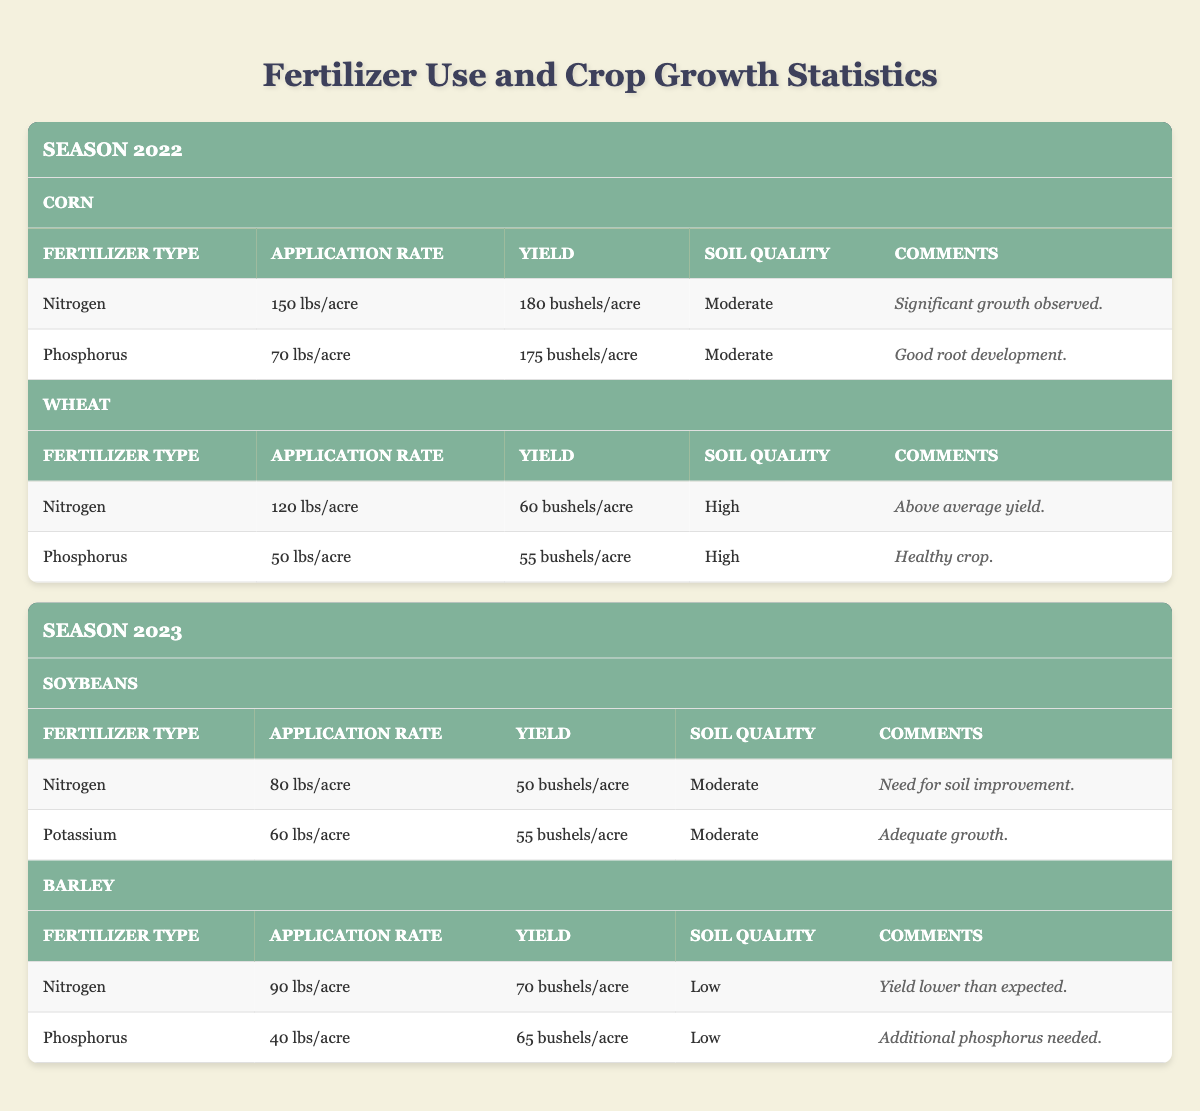What is the yield of corn for the 2022 season? The yield for corn in the 2022 season is listed under the respective row for corn in that season. Looking closely, it indicates a yield of 180 bushels/acre.
Answer: 180 bushels/acre What type of fertilizer was used for wheat in the 2022 season? The table has a specific row for wheat in the 2022 season that lists the fertilizers used. The types listed are nitrogen and phosphorus.
Answer: Nitrogen and phosphorus Which crop had a higher yield in 2022, corn or wheat? By comparing the yields listed in the table, corn has a yield of 180 bushels/acre, while wheat has a yield of 60 bushels/acre. Clearly, corn has a higher yield than wheat.
Answer: Corn What was the total application rate of nitrogen used for corn in the 2022 season? The application rate for nitrogen for corn is given directly in the table as 150 lbs/acre. This is the single fertilizer application rate for corn in that season.
Answer: 150 lbs/acre Does the 2023 season show an increase in yield for soybeans compared to the yield of wheat in the 2022 season? The yield for soybeans in 2023 is 50 bushels/acre, while the yield for wheat in 2022 is 60 bushels/acre. Therefore, the yield for soybeans did not increase compared to wheat; it decreased.
Answer: No What is the average yield of barley in the 2023 season? Both nitrogen and phosphorus applications are listed for barley with respective yields of 70 bushels/acre and 65 bushels/acre. To find the average, we calculate (70 + 65) / 2 = 67.5 bushels/acre.
Answer: 67.5 bushels/acre Which fertilizer type contributed to the lowest yield for barley in 2023? The yield for nitrogen applied to barley is recorded as 70 bushels/acre, while phosphorus gave a yield of 65 bushels/acre. By comparing these values, phosphorus yielded the lowest.
Answer: Phosphorus Is the soil quality for soybeans in 2023 moderate? The table states that the soil quality for soybeans is categorized as moderate. Thus, the statement is true based on this data.
Answer: Yes What are the comments regarding the nitrogen application for soybeans in 2023? The comments section for the nitrogen application for soybeans details that there is a need for soil improvement, found directly in the table under the relevant crop and fertilizer type.
Answer: Need for soil improvement 